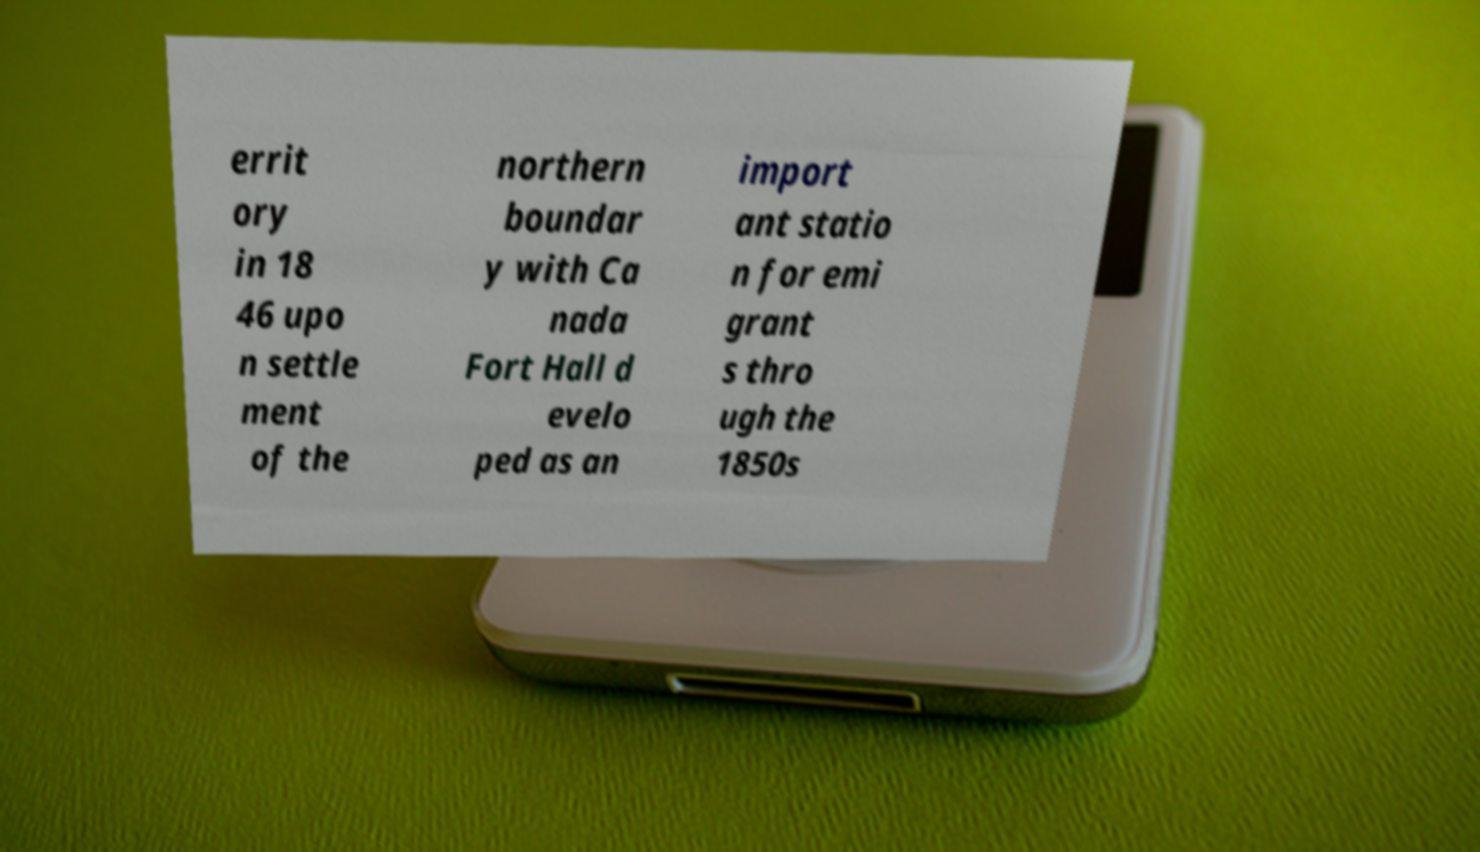Can you accurately transcribe the text from the provided image for me? errit ory in 18 46 upo n settle ment of the northern boundar y with Ca nada Fort Hall d evelo ped as an import ant statio n for emi grant s thro ugh the 1850s 